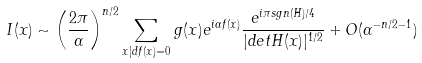<formula> <loc_0><loc_0><loc_500><loc_500>I ( x ) \sim \left ( \frac { 2 \pi } { \alpha } \right ) ^ { n / 2 } \sum _ { x | d f ( x ) = 0 } g ( x ) e ^ { i \alpha f ( x ) } \frac { e ^ { i \pi s g n ( H ) / 4 } } { | d e t H ( x ) | ^ { 1 / 2 } } + O ( \alpha ^ { - n / 2 - 1 } )</formula> 